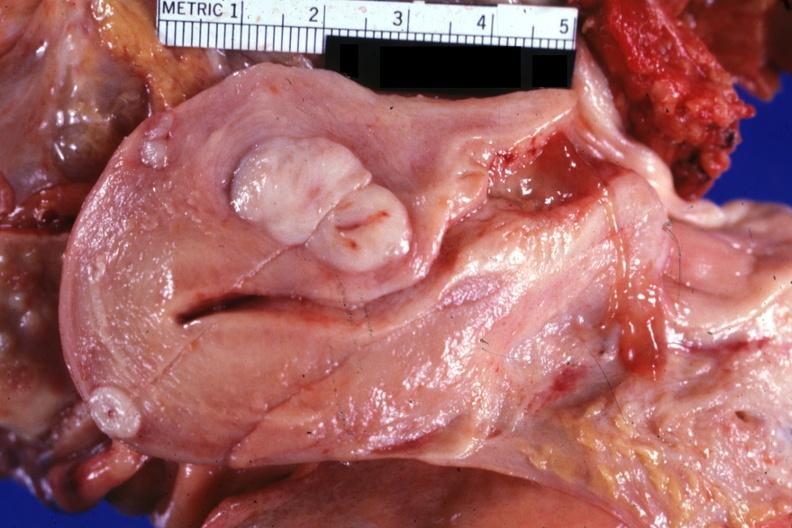s infant body present?
Answer the question using a single word or phrase. No 